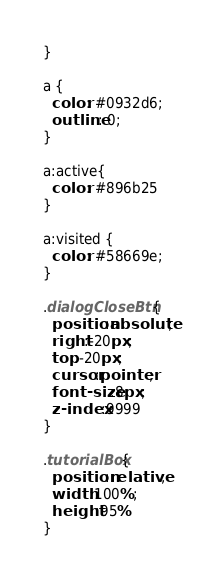Convert code to text. <code><loc_0><loc_0><loc_500><loc_500><_CSS_>}

a {
  color: #0932d6;
  outline: 0;
}

a:active{
  color: #896b25
}

a:visited {
  color: #58669e;
}

.dialogCloseBtn {
  position:absolute;
  right:-20px;
  top:-20px;
  cursor:pointer;
  font-size:8px;
  z-index:9999
}

.tutorialBox{
  position:relative;
  width:100%;
  height:95%
}
</code> 